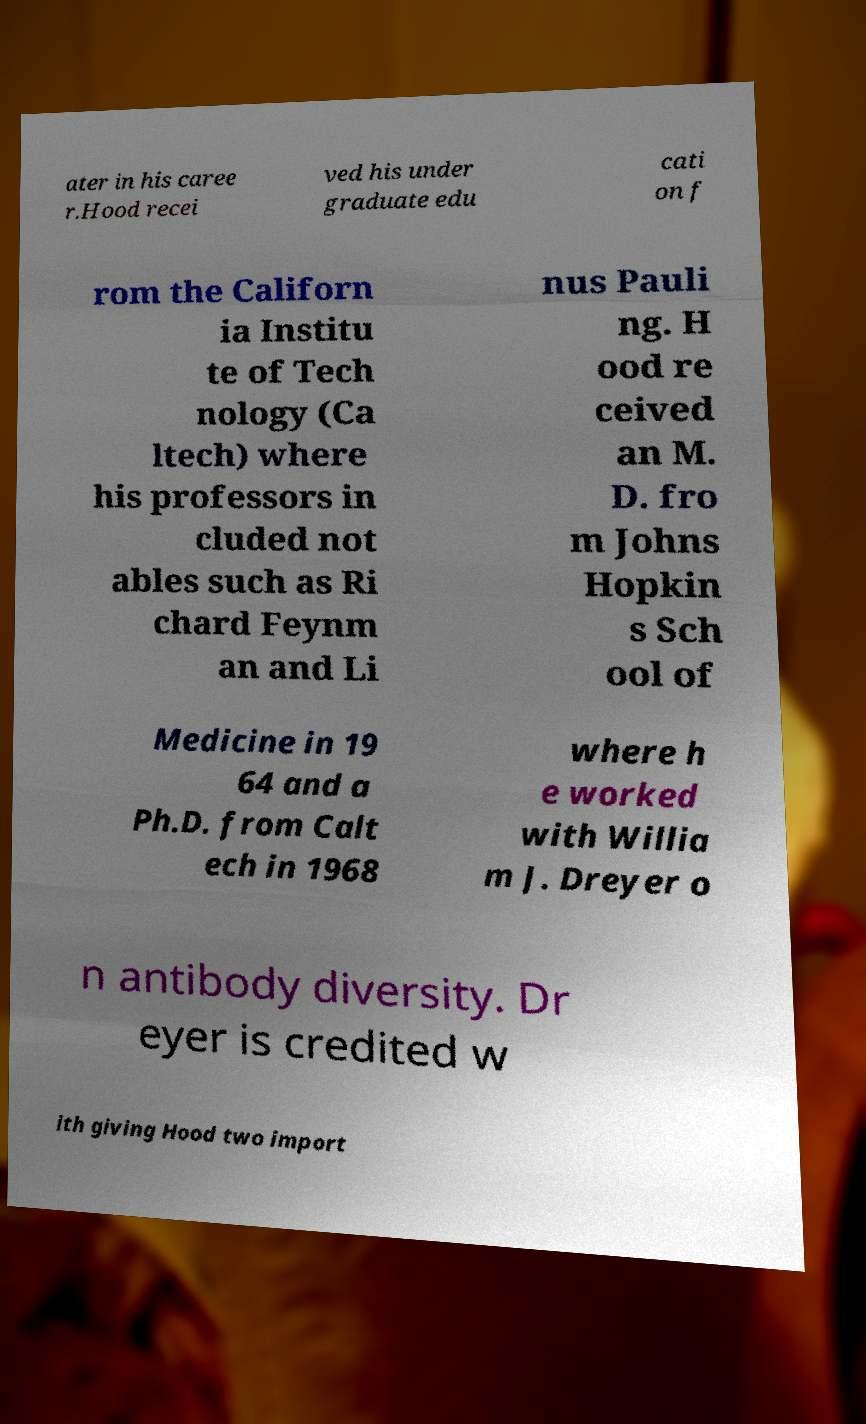Please read and relay the text visible in this image. What does it say? ater in his caree r.Hood recei ved his under graduate edu cati on f rom the Californ ia Institu te of Tech nology (Ca ltech) where his professors in cluded not ables such as Ri chard Feynm an and Li nus Pauli ng. H ood re ceived an M. D. fro m Johns Hopkin s Sch ool of Medicine in 19 64 and a Ph.D. from Calt ech in 1968 where h e worked with Willia m J. Dreyer o n antibody diversity. Dr eyer is credited w ith giving Hood two import 